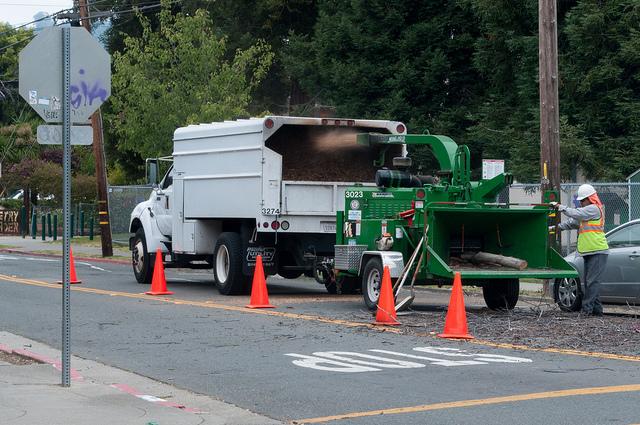What is the sign on the corner?
Write a very short answer. Stop. What is the machine used for?
Answer briefly. Mulching. Are there people on the street?
Concise answer only. Yes. Is this a dangerous machine if not used carefully?
Concise answer only. Yes. 